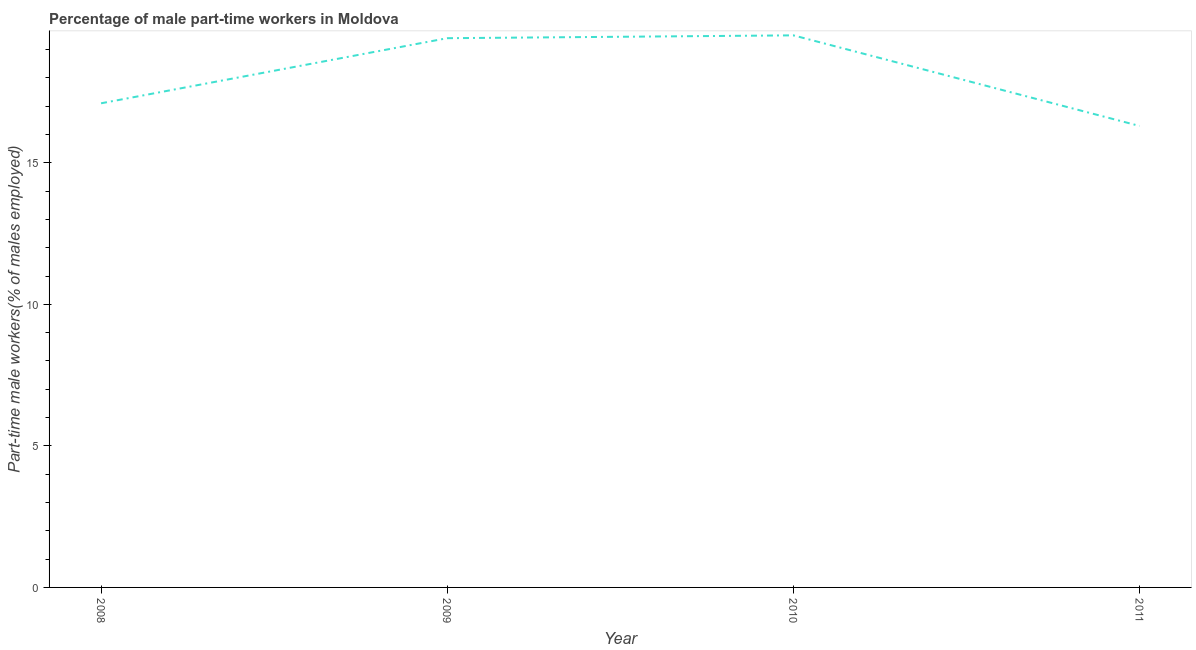What is the percentage of part-time male workers in 2008?
Give a very brief answer. 17.1. Across all years, what is the minimum percentage of part-time male workers?
Provide a short and direct response. 16.3. In which year was the percentage of part-time male workers maximum?
Keep it short and to the point. 2010. In which year was the percentage of part-time male workers minimum?
Provide a short and direct response. 2011. What is the sum of the percentage of part-time male workers?
Provide a short and direct response. 72.3. What is the difference between the percentage of part-time male workers in 2008 and 2011?
Provide a succinct answer. 0.8. What is the average percentage of part-time male workers per year?
Your answer should be very brief. 18.07. What is the median percentage of part-time male workers?
Make the answer very short. 18.25. What is the ratio of the percentage of part-time male workers in 2009 to that in 2010?
Make the answer very short. 0.99. Is the percentage of part-time male workers in 2008 less than that in 2009?
Keep it short and to the point. Yes. Is the difference between the percentage of part-time male workers in 2009 and 2011 greater than the difference between any two years?
Provide a short and direct response. No. What is the difference between the highest and the second highest percentage of part-time male workers?
Keep it short and to the point. 0.1. Is the sum of the percentage of part-time male workers in 2010 and 2011 greater than the maximum percentage of part-time male workers across all years?
Your answer should be very brief. Yes. What is the difference between the highest and the lowest percentage of part-time male workers?
Ensure brevity in your answer.  3.2. How many lines are there?
Provide a short and direct response. 1. How many years are there in the graph?
Keep it short and to the point. 4. What is the difference between two consecutive major ticks on the Y-axis?
Ensure brevity in your answer.  5. Are the values on the major ticks of Y-axis written in scientific E-notation?
Ensure brevity in your answer.  No. Does the graph contain grids?
Your answer should be very brief. No. What is the title of the graph?
Offer a very short reply. Percentage of male part-time workers in Moldova. What is the label or title of the X-axis?
Your response must be concise. Year. What is the label or title of the Y-axis?
Provide a short and direct response. Part-time male workers(% of males employed). What is the Part-time male workers(% of males employed) in 2008?
Your answer should be very brief. 17.1. What is the Part-time male workers(% of males employed) in 2009?
Keep it short and to the point. 19.4. What is the Part-time male workers(% of males employed) in 2011?
Provide a short and direct response. 16.3. What is the difference between the Part-time male workers(% of males employed) in 2008 and 2009?
Give a very brief answer. -2.3. What is the difference between the Part-time male workers(% of males employed) in 2010 and 2011?
Keep it short and to the point. 3.2. What is the ratio of the Part-time male workers(% of males employed) in 2008 to that in 2009?
Offer a very short reply. 0.88. What is the ratio of the Part-time male workers(% of males employed) in 2008 to that in 2010?
Your answer should be compact. 0.88. What is the ratio of the Part-time male workers(% of males employed) in 2008 to that in 2011?
Your answer should be compact. 1.05. What is the ratio of the Part-time male workers(% of males employed) in 2009 to that in 2010?
Your answer should be compact. 0.99. What is the ratio of the Part-time male workers(% of males employed) in 2009 to that in 2011?
Your answer should be compact. 1.19. What is the ratio of the Part-time male workers(% of males employed) in 2010 to that in 2011?
Provide a succinct answer. 1.2. 